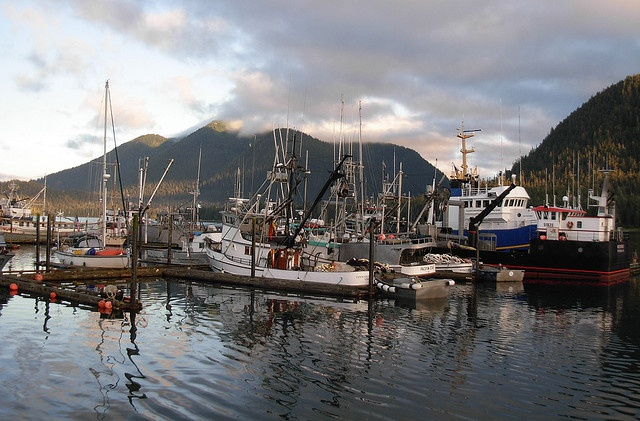Describe the objects in this image and their specific colors. I can see boat in lightblue, black, darkgray, gray, and maroon tones, boat in lightblue, black, gray, and darkgray tones, boat in lightblue, darkgray, black, gray, and maroon tones, boat in lightblue, darkgray, gray, lightgray, and black tones, and boat in lightblue, gray, black, and darkgray tones in this image. 